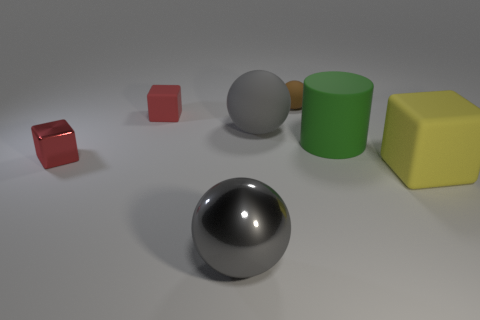Are there any green things?
Keep it short and to the point. Yes. Are there any small brown balls made of the same material as the yellow object?
Ensure brevity in your answer.  Yes. Is there anything else that has the same material as the cylinder?
Offer a very short reply. Yes. The big matte ball has what color?
Give a very brief answer. Gray. The other tiny object that is the same color as the tiny shiny thing is what shape?
Your answer should be compact. Cube. What is the color of the metallic cube that is the same size as the brown rubber sphere?
Make the answer very short. Red. What number of metallic objects are yellow cylinders or big green cylinders?
Keep it short and to the point. 0. What number of large rubber objects are on the left side of the small brown rubber thing and to the right of the green rubber object?
Offer a very short reply. 0. Are there any other things that are the same shape as the green rubber object?
Ensure brevity in your answer.  No. What number of other objects are there of the same size as the yellow rubber cube?
Provide a succinct answer. 3. 